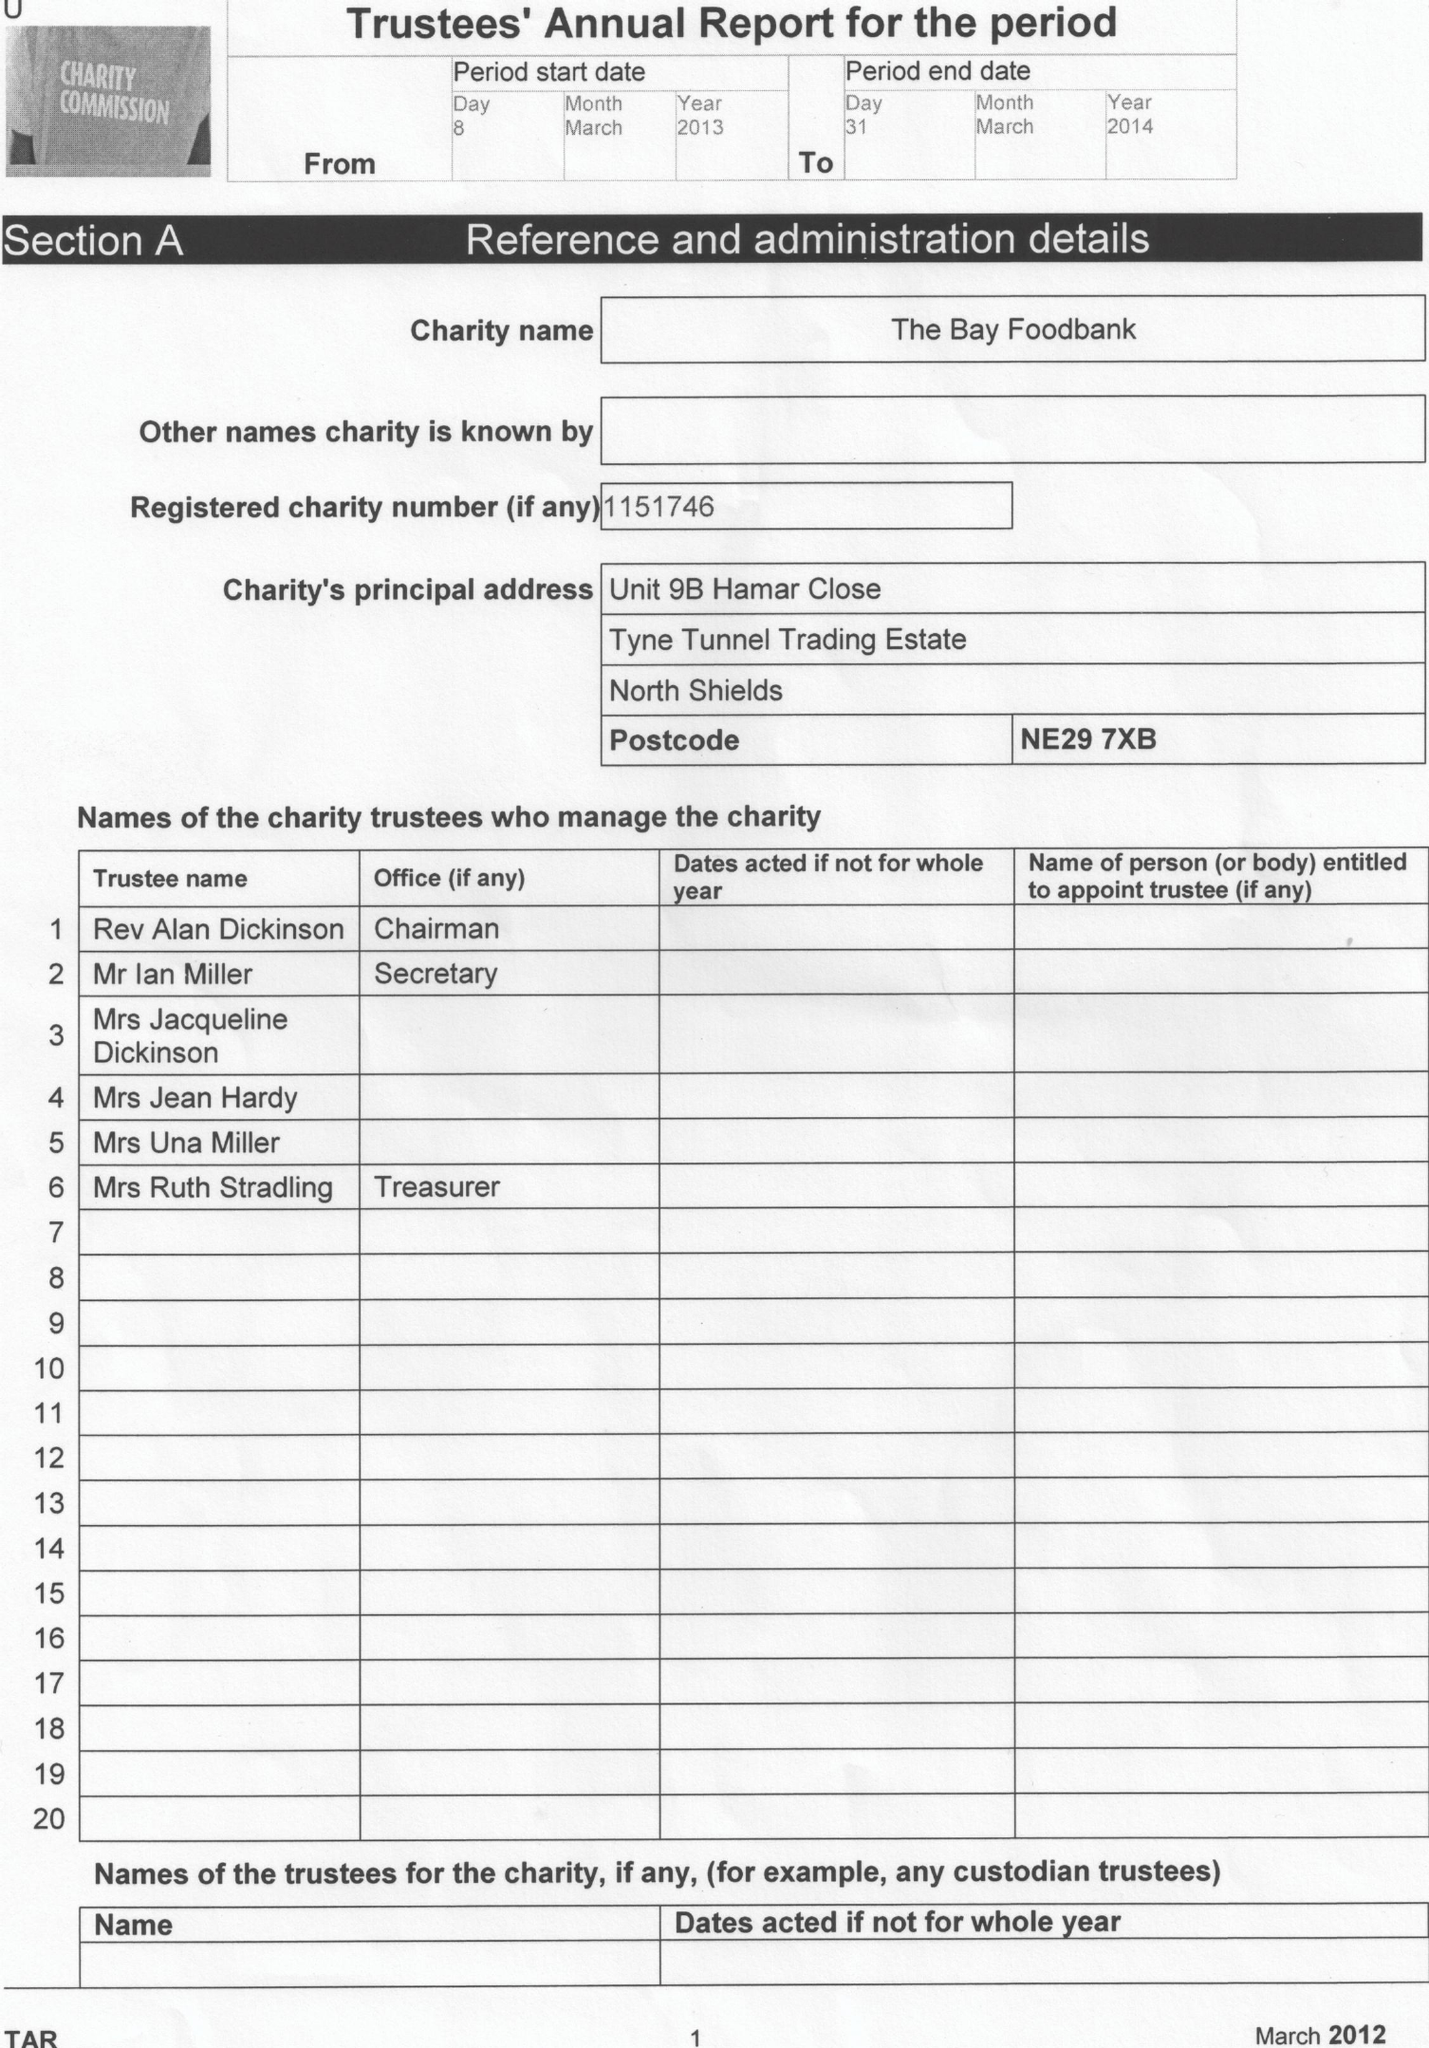What is the value for the income_annually_in_british_pounds?
Answer the question using a single word or phrase. 66978.00 